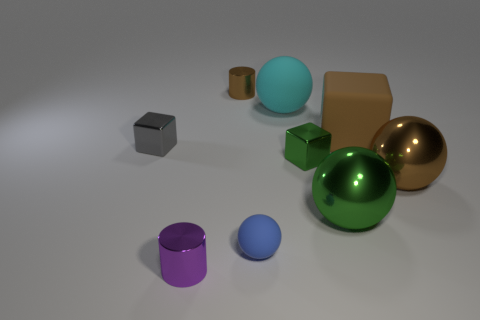The big matte object in front of the matte ball behind the thing that is left of the tiny purple thing is what color?
Make the answer very short. Brown. Are there more small metallic cubes that are right of the big cyan matte ball than big brown matte cubes in front of the small green metallic block?
Make the answer very short. Yes. What number of other objects are the same size as the gray metallic block?
Your response must be concise. 4. The ball that is the same color as the large cube is what size?
Provide a short and direct response. Large. The big sphere left of the green shiny object that is in front of the green cube is made of what material?
Provide a succinct answer. Rubber. Are there any big things in front of the green metal cube?
Provide a succinct answer. Yes. Are there more tiny shiny cylinders behind the big matte cube than big red rubber cylinders?
Provide a succinct answer. Yes. Are there any metal objects of the same color as the large cube?
Your answer should be very brief. Yes. There is a block that is the same size as the cyan sphere; what color is it?
Provide a short and direct response. Brown. There is a metal thing that is left of the tiny purple shiny cylinder; is there a brown sphere that is behind it?
Your response must be concise. No. 